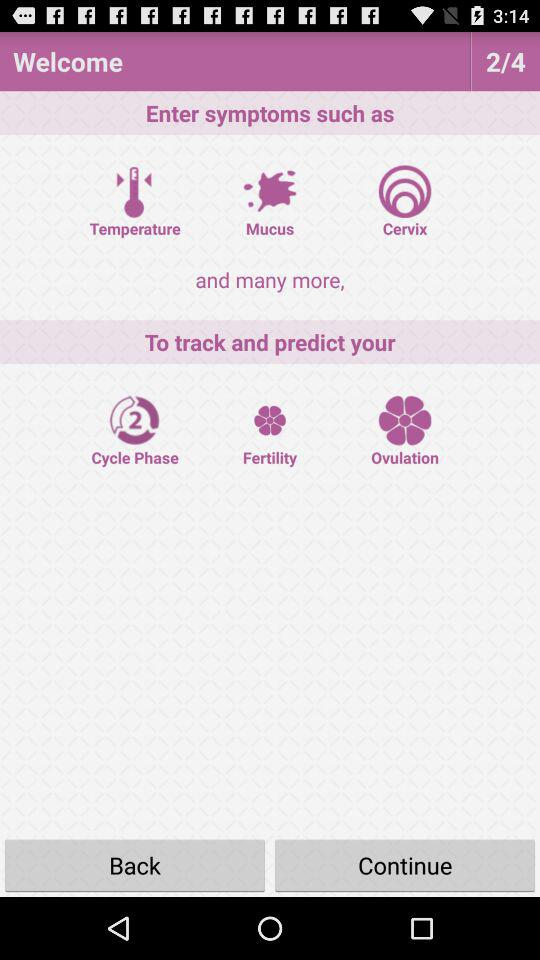What is the total number of pages? The total number of pages is 4. 